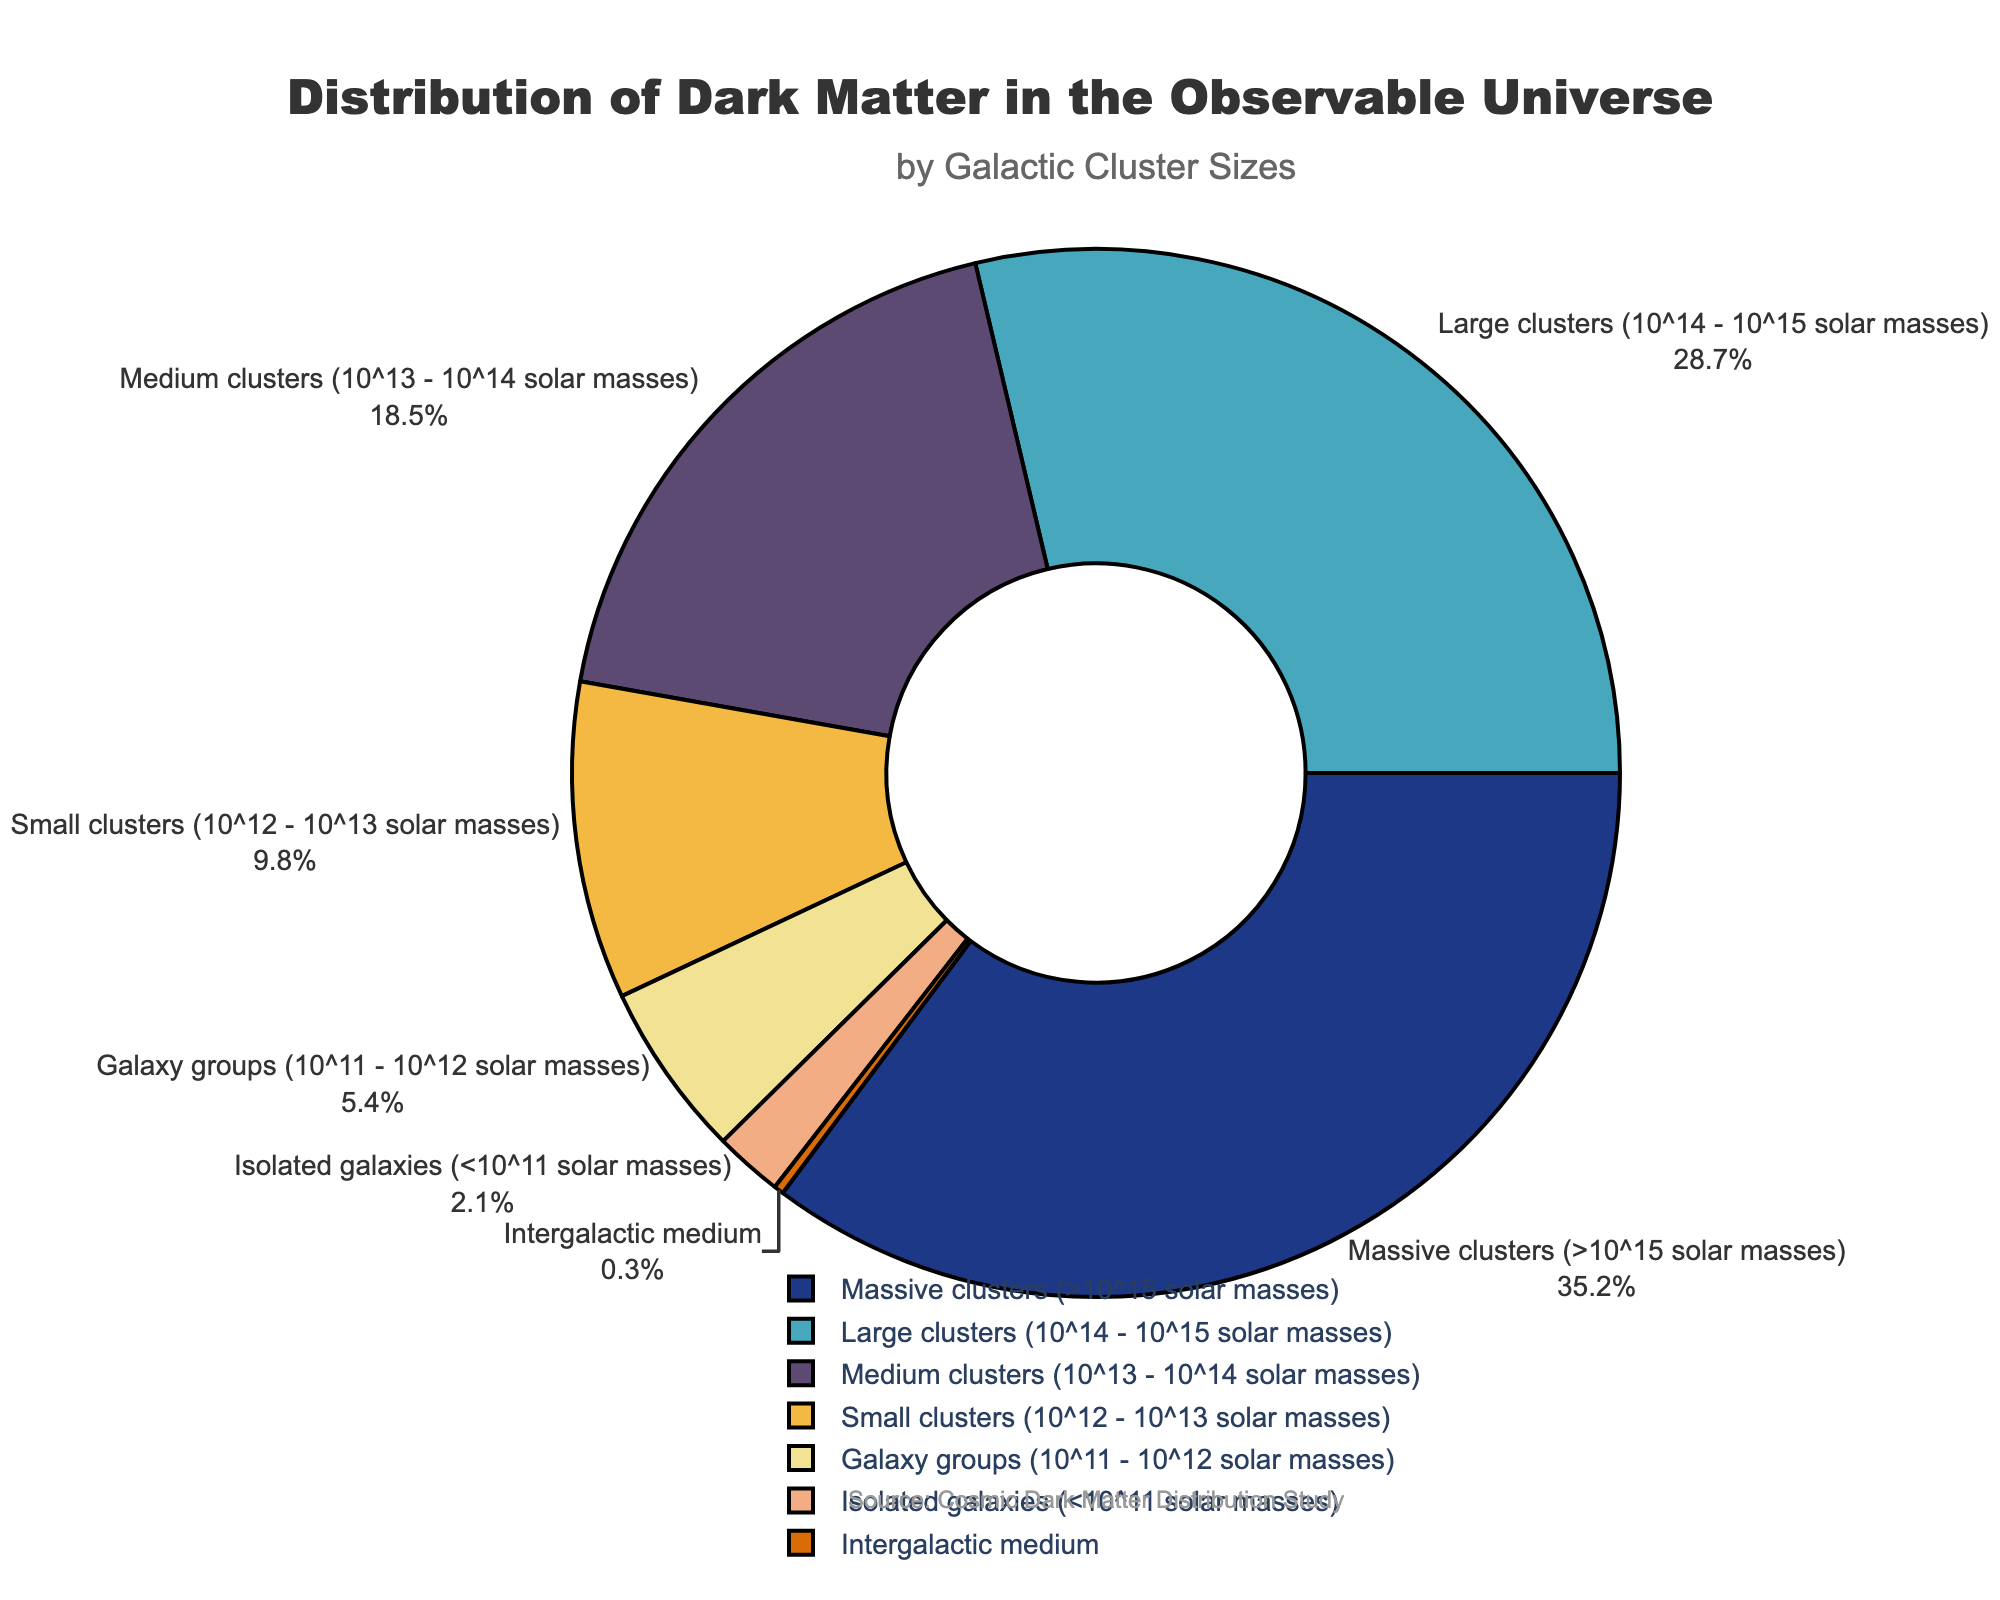What percentage of dark matter is found in medium and small clusters combined? To find the combined percentage of dark matter in medium and small clusters, add the percentages for these two categories: 18.5% (medium) + 9.8% (small) = 28.3%.
Answer: 28.3% Which cluster size category has the highest percentage of dark matter? By looking at the pie chart, the "Massive clusters (>10^15 solar masses)" category has the highest percentage, which is 35.2%.
Answer: Massive clusters (>10^15 solar masses) Are galaxy groups or isolated galaxies responsible for a higher percentage of dark matter? To compare these two categories, check their percentages from the pie chart: Galaxy groups (5.4%) and Isolated galaxies (2.1%). Galaxy groups have a higher percentage.
Answer: Galaxy groups Is the percentage of dark matter in the intergalactic medium greater or less than 1%? By observing the pie chart, the "Intergalactic medium" category has a percentage of 0.3%, which is less than 1%.
Answer: Less than 1% What is the total percentage of dark matter in all clusters larger than or equal to 10^13 solar masses? Sum the percentages of "Massive clusters", "Large clusters", and "Medium clusters": 35.2% + 28.7% + 18.5% = 82.4%.
Answer: 82.4% Which category has a slightly higher percentage of dark matter: small clusters or galaxy groups? Compare the percentages of "Small clusters" (9.8%) and "Galaxy groups" (5.4%) from the pie chart; small clusters have a higher percentage.
Answer: Small clusters What is the combined percentage of dark matter in galaxy groups and isolated galaxies? Sum the percentages of "Galaxy groups" and "Isolated galaxies": 5.4% + 2.1% = 7.5%.
Answer: 7.5% Is the percentage of dark matter in large clusters closer to 20% or 30%? The percentage of dark matter in "Large clusters" is 28.7%, which is closer to 30%.
Answer: 30% 